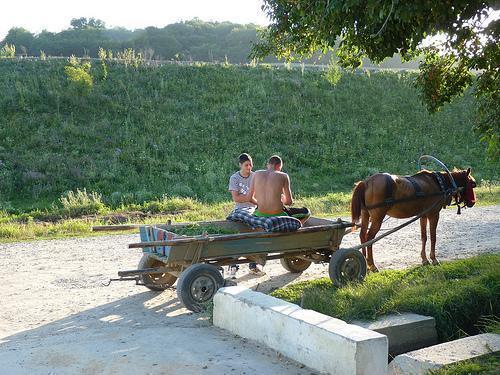How many people are in the picture?
Give a very brief answer. 2. How many wheels are on the cart?
Give a very brief answer. 4. How many people are in the cart?
Give a very brief answer. 1. 